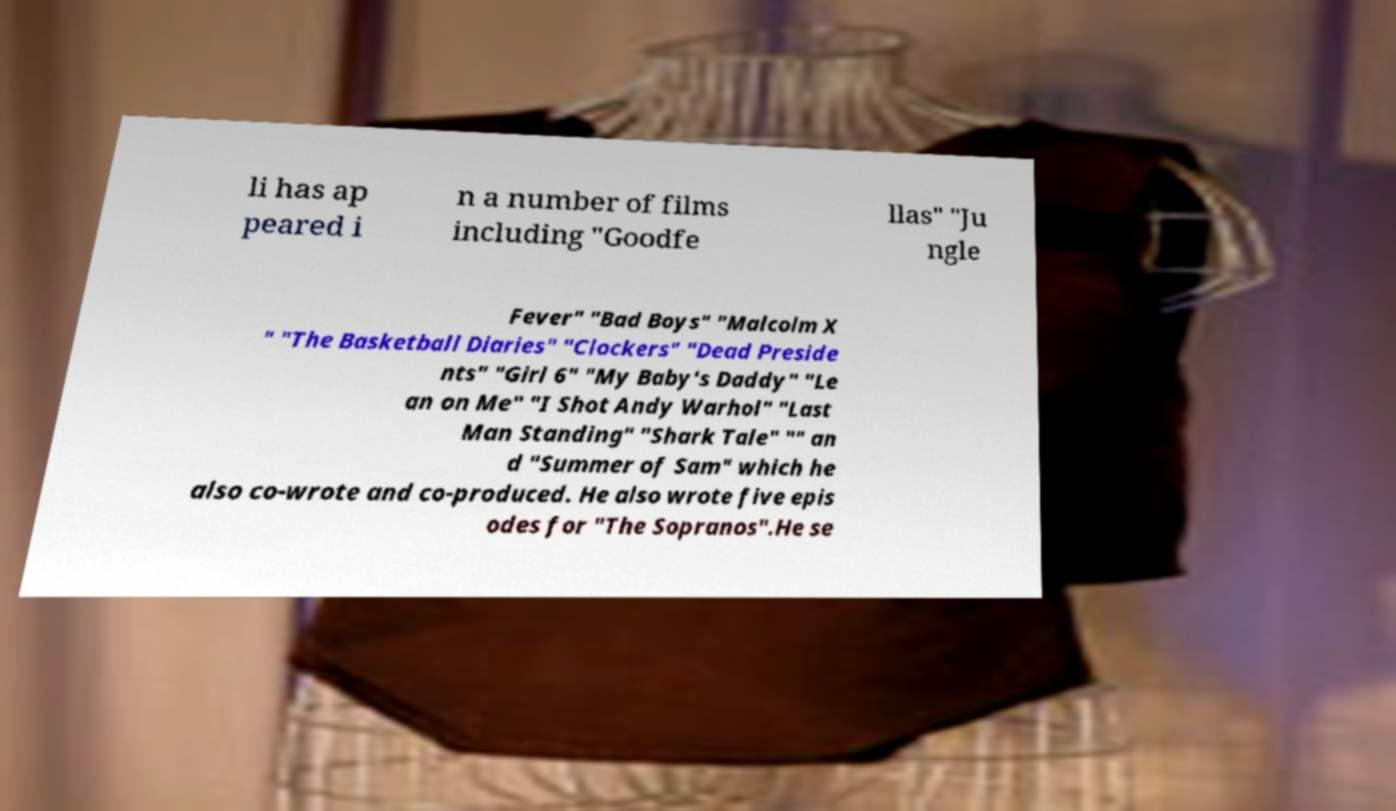There's text embedded in this image that I need extracted. Can you transcribe it verbatim? li has ap peared i n a number of films including "Goodfe llas" "Ju ngle Fever" "Bad Boys" "Malcolm X " "The Basketball Diaries" "Clockers" "Dead Preside nts" "Girl 6" "My Baby's Daddy" "Le an on Me" "I Shot Andy Warhol" "Last Man Standing" "Shark Tale" "" an d "Summer of Sam" which he also co-wrote and co-produced. He also wrote five epis odes for "The Sopranos".He se 